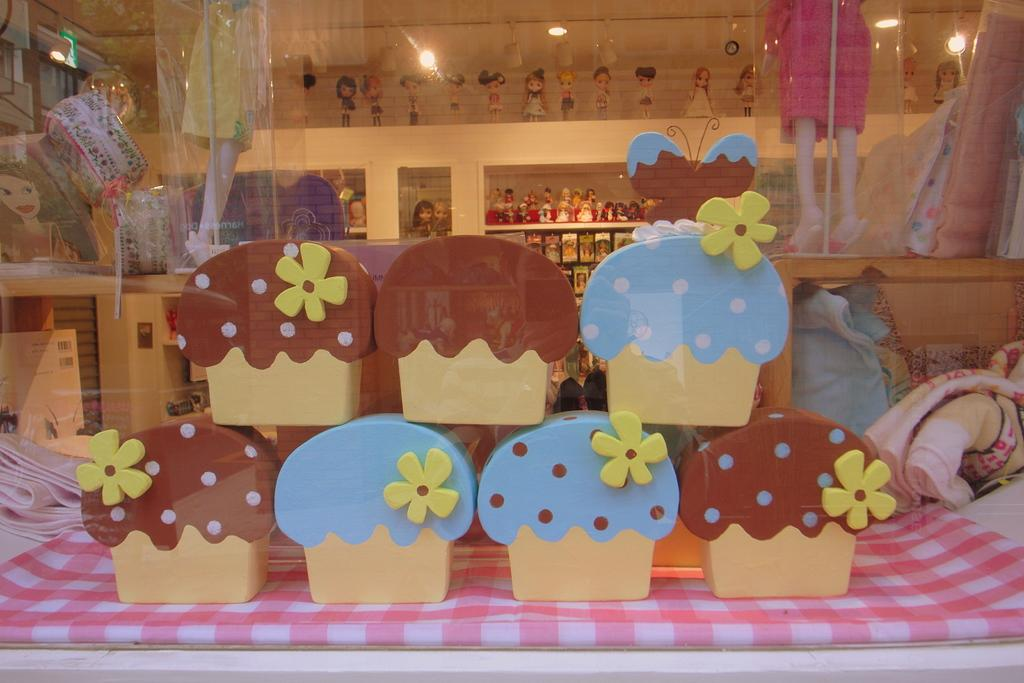What is located on the table in the image? There are objects on the table in the image. What can be seen in the background of the image? There are lights visible in the background. What type of items are stored in the background? There are toys in racks in the background. What type of lace is draped over the table in the image? There is no lace present in the image. What type of flag is visible in the background of the image? There is no flag visible in the image. 